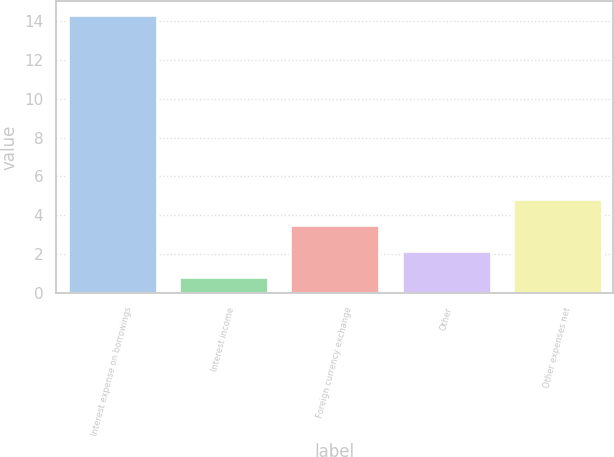Convert chart to OTSL. <chart><loc_0><loc_0><loc_500><loc_500><bar_chart><fcel>Interest expense on borrowings<fcel>Interest income<fcel>Foreign currency exchange<fcel>Other<fcel>Other expenses net<nl><fcel>14.3<fcel>0.8<fcel>3.5<fcel>2.15<fcel>4.85<nl></chart> 